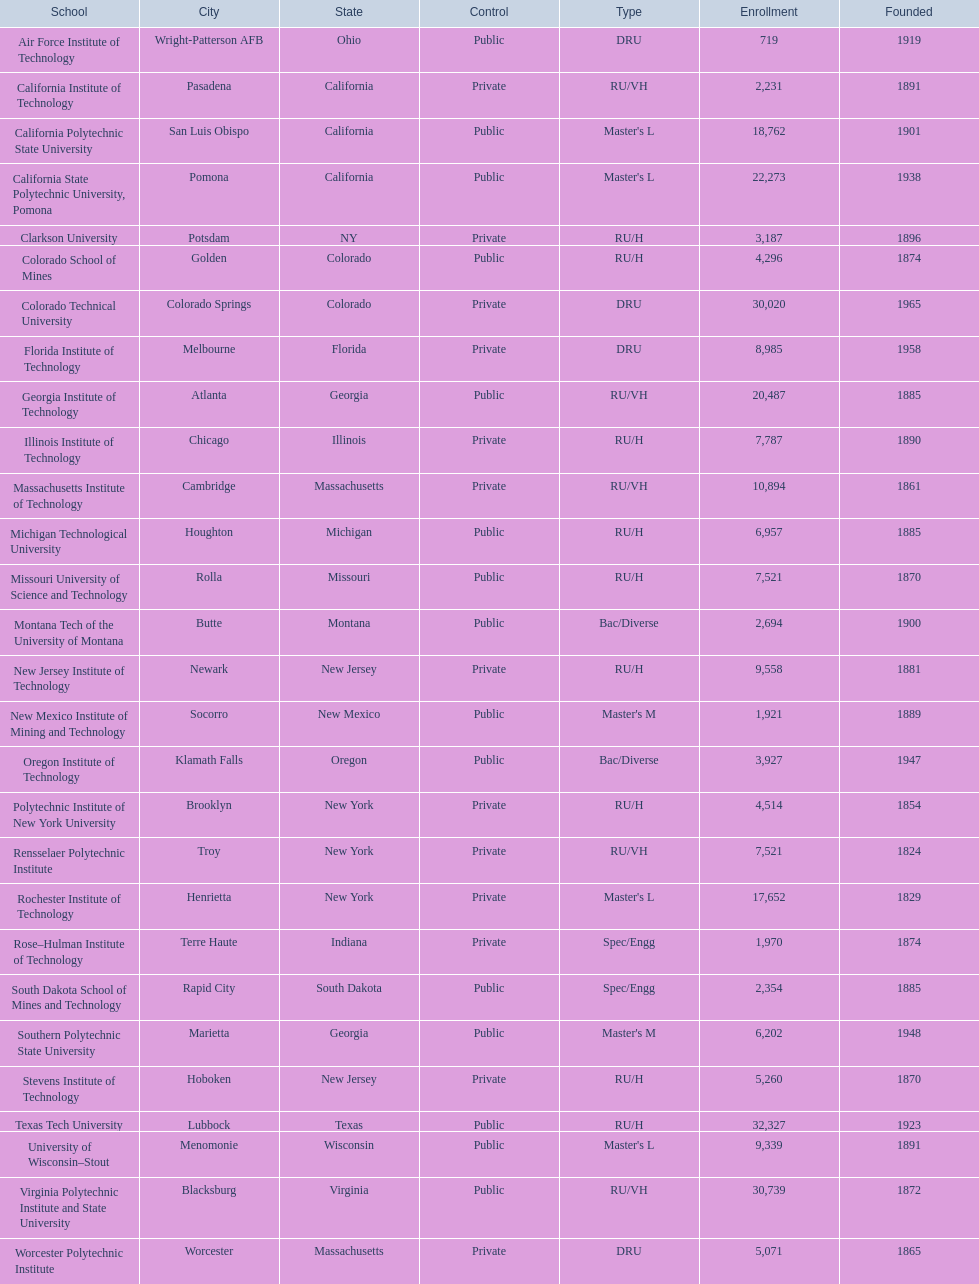What are all the schools? Air Force Institute of Technology, California Institute of Technology, California Polytechnic State University, California State Polytechnic University, Pomona, Clarkson University, Colorado School of Mines, Colorado Technical University, Florida Institute of Technology, Georgia Institute of Technology, Illinois Institute of Technology, Massachusetts Institute of Technology, Michigan Technological University, Missouri University of Science and Technology, Montana Tech of the University of Montana, New Jersey Institute of Technology, New Mexico Institute of Mining and Technology, Oregon Institute of Technology, Polytechnic Institute of New York University, Rensselaer Polytechnic Institute, Rochester Institute of Technology, Rose–Hulman Institute of Technology, South Dakota School of Mines and Technology, Southern Polytechnic State University, Stevens Institute of Technology, Texas Tech University, University of Wisconsin–Stout, Virginia Polytechnic Institute and State University, Worcester Polytechnic Institute. What is the enrollment of each school? 719, 2,231, 18,762, 22,273, 3,187, 4,296, 30,020, 8,985, 20,487, 7,787, 10,894, 6,957, 7,521, 2,694, 9,558, 1,921, 3,927, 4,514, 7,521, 17,652, 1,970, 2,354, 6,202, 5,260, 32,327, 9,339, 30,739, 5,071. And which school had the highest enrollment? Texas Tech University. 